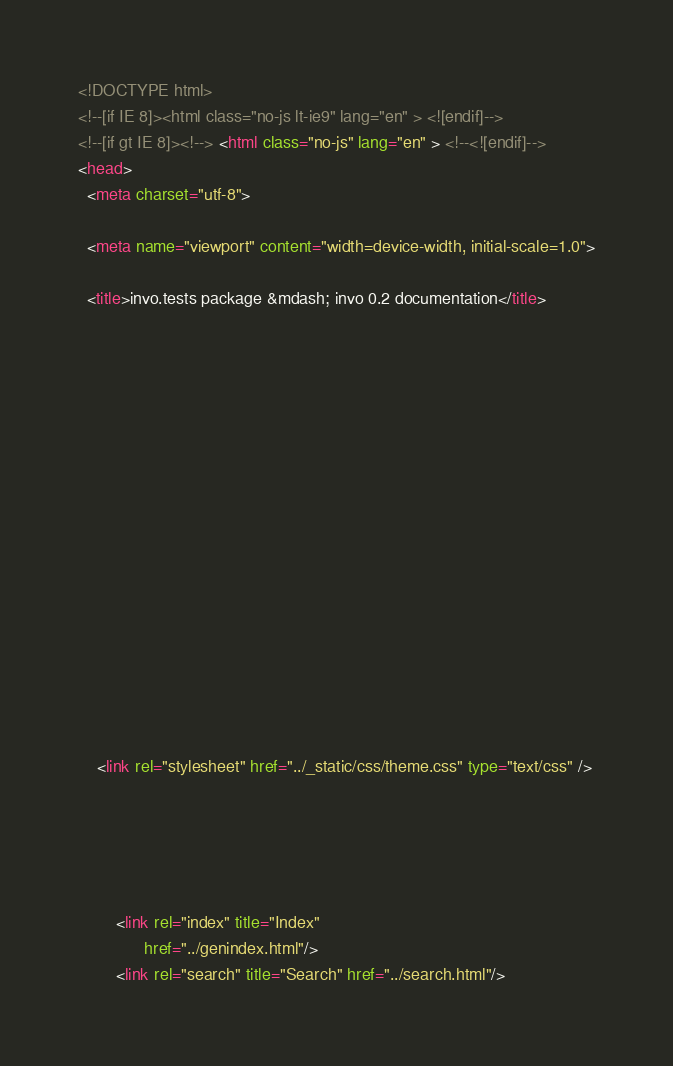Convert code to text. <code><loc_0><loc_0><loc_500><loc_500><_HTML_>

<!DOCTYPE html>
<!--[if IE 8]><html class="no-js lt-ie9" lang="en" > <![endif]-->
<!--[if gt IE 8]><!--> <html class="no-js" lang="en" > <!--<![endif]-->
<head>
  <meta charset="utf-8">
  
  <meta name="viewport" content="width=device-width, initial-scale=1.0">
  
  <title>invo.tests package &mdash; invo 0.2 documentation</title>
  

  
  
  
  

  

  
  
    

  

  
  
    <link rel="stylesheet" href="../_static/css/theme.css" type="text/css" />
  

  

  
        <link rel="index" title="Index"
              href="../genindex.html"/>
        <link rel="search" title="Search" href="../search.html"/></code> 